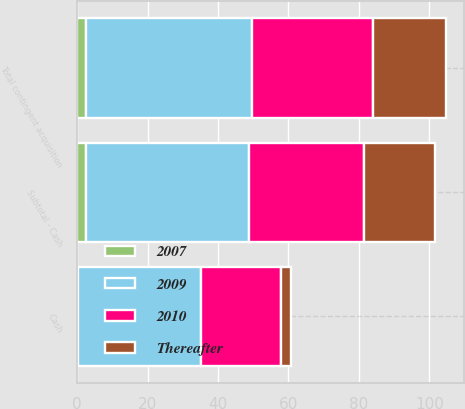Convert chart. <chart><loc_0><loc_0><loc_500><loc_500><stacked_bar_chart><ecel><fcel>Cash<fcel>Subtotal - Cash<fcel>Total contingent acquisition<nl><fcel>2009<fcel>35.1<fcel>46.5<fcel>47.2<nl><fcel>2010<fcel>22.5<fcel>32.5<fcel>34.2<nl><fcel>Thereafter<fcel>2.9<fcel>20.3<fcel>20.8<nl><fcel>2007<fcel>0.2<fcel>2.4<fcel>2.5<nl></chart> 